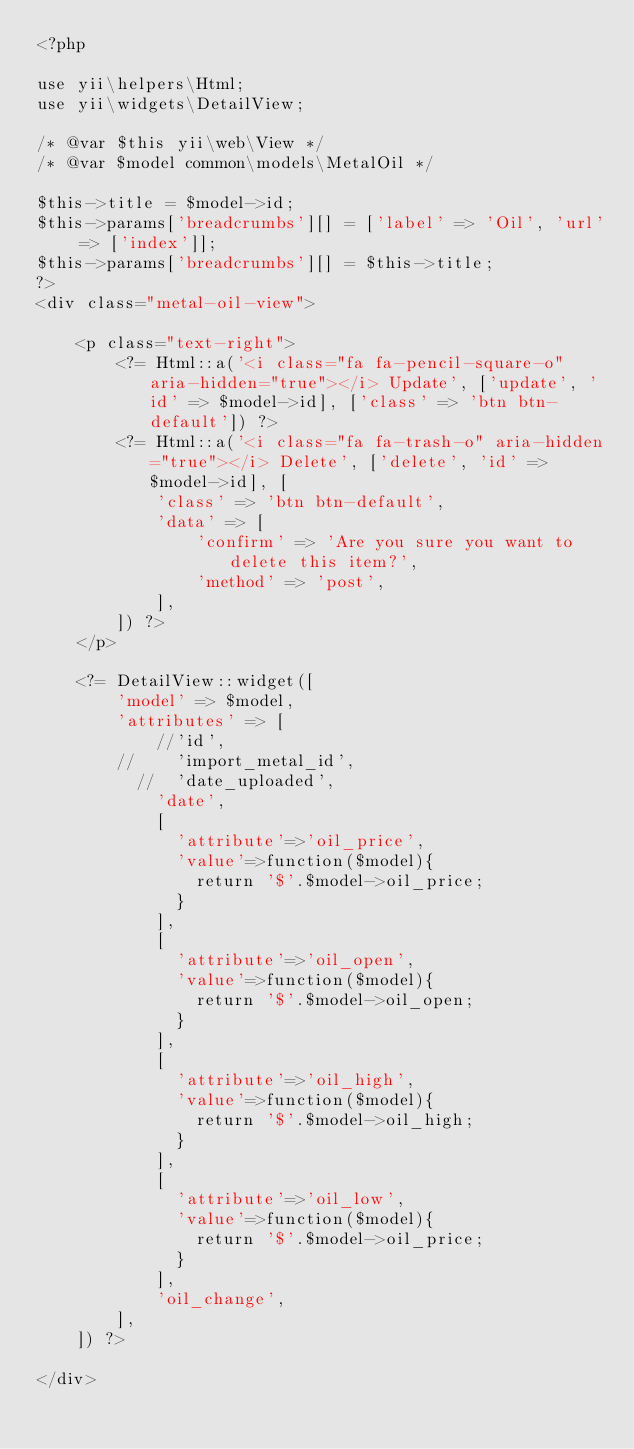<code> <loc_0><loc_0><loc_500><loc_500><_PHP_><?php

use yii\helpers\Html;
use yii\widgets\DetailView;

/* @var $this yii\web\View */
/* @var $model common\models\MetalOil */

$this->title = $model->id;
$this->params['breadcrumbs'][] = ['label' => 'Oil', 'url' => ['index']];
$this->params['breadcrumbs'][] = $this->title;
?>
<div class="metal-oil-view">

    <p class="text-right">
        <?= Html::a('<i class="fa fa-pencil-square-o" aria-hidden="true"></i> Update', ['update', 'id' => $model->id], ['class' => 'btn btn-default']) ?>
        <?= Html::a('<i class="fa fa-trash-o" aria-hidden="true"></i> Delete', ['delete', 'id' => $model->id], [
            'class' => 'btn btn-default',
            'data' => [
                'confirm' => 'Are you sure you want to delete this item?',
                'method' => 'post',
            ],
        ]) ?>
    </p>

    <?= DetailView::widget([
        'model' => $model,
        'attributes' => [
            //'id',
        //    'import_metal_id',
          //  'date_uploaded',
            'date',
            [
              'attribute'=>'oil_price',
              'value'=>function($model){
                return '$'.$model->oil_price;
              }
            ],
            [
              'attribute'=>'oil_open',
              'value'=>function($model){
                return '$'.$model->oil_open;
              }
            ],
            [
              'attribute'=>'oil_high',
              'value'=>function($model){
                return '$'.$model->oil_high;
              }
            ],
            [
              'attribute'=>'oil_low',
              'value'=>function($model){
                return '$'.$model->oil_price;
              }
            ],
            'oil_change',
        ],
    ]) ?>

</div>
</code> 